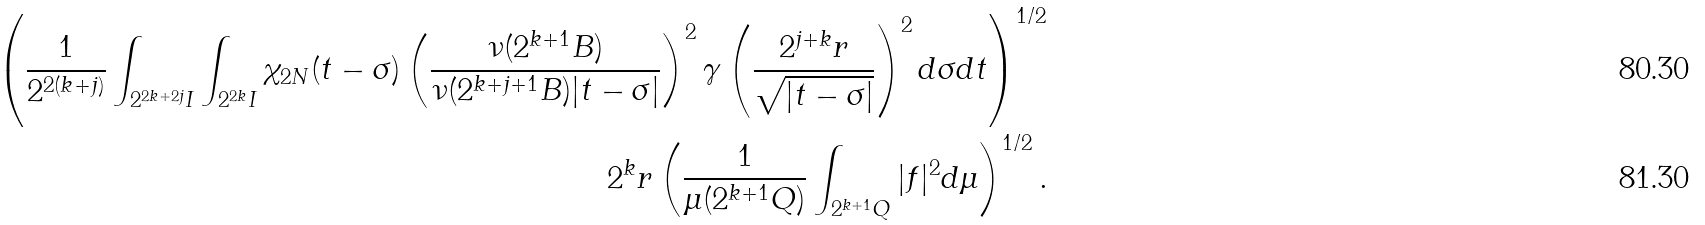<formula> <loc_0><loc_0><loc_500><loc_500>\left ( \frac { 1 } { 2 ^ { 2 ( k + j ) } } \int _ { 2 ^ { 2 k + 2 j } I } \int _ { 2 ^ { 2 k } I } \chi _ { 2 N } ( t - \sigma ) \left ( \frac { \nu ( 2 ^ { k + 1 } B ) } { \nu ( 2 ^ { k + j + 1 } B ) | t - \sigma | } \right ) ^ { 2 } \gamma \left ( \frac { 2 ^ { j + k } r } { \sqrt { | t - \sigma | } } \right ) ^ { 2 } d \sigma d t \right ) ^ { 1 / 2 } \\ \quad 2 ^ { k } r \left ( \frac { 1 } { \mu ( 2 ^ { k + 1 } Q ) } \int _ { 2 ^ { k + 1 } Q } | f | ^ { 2 } d \mu \right ) ^ { 1 / 2 } .</formula> 